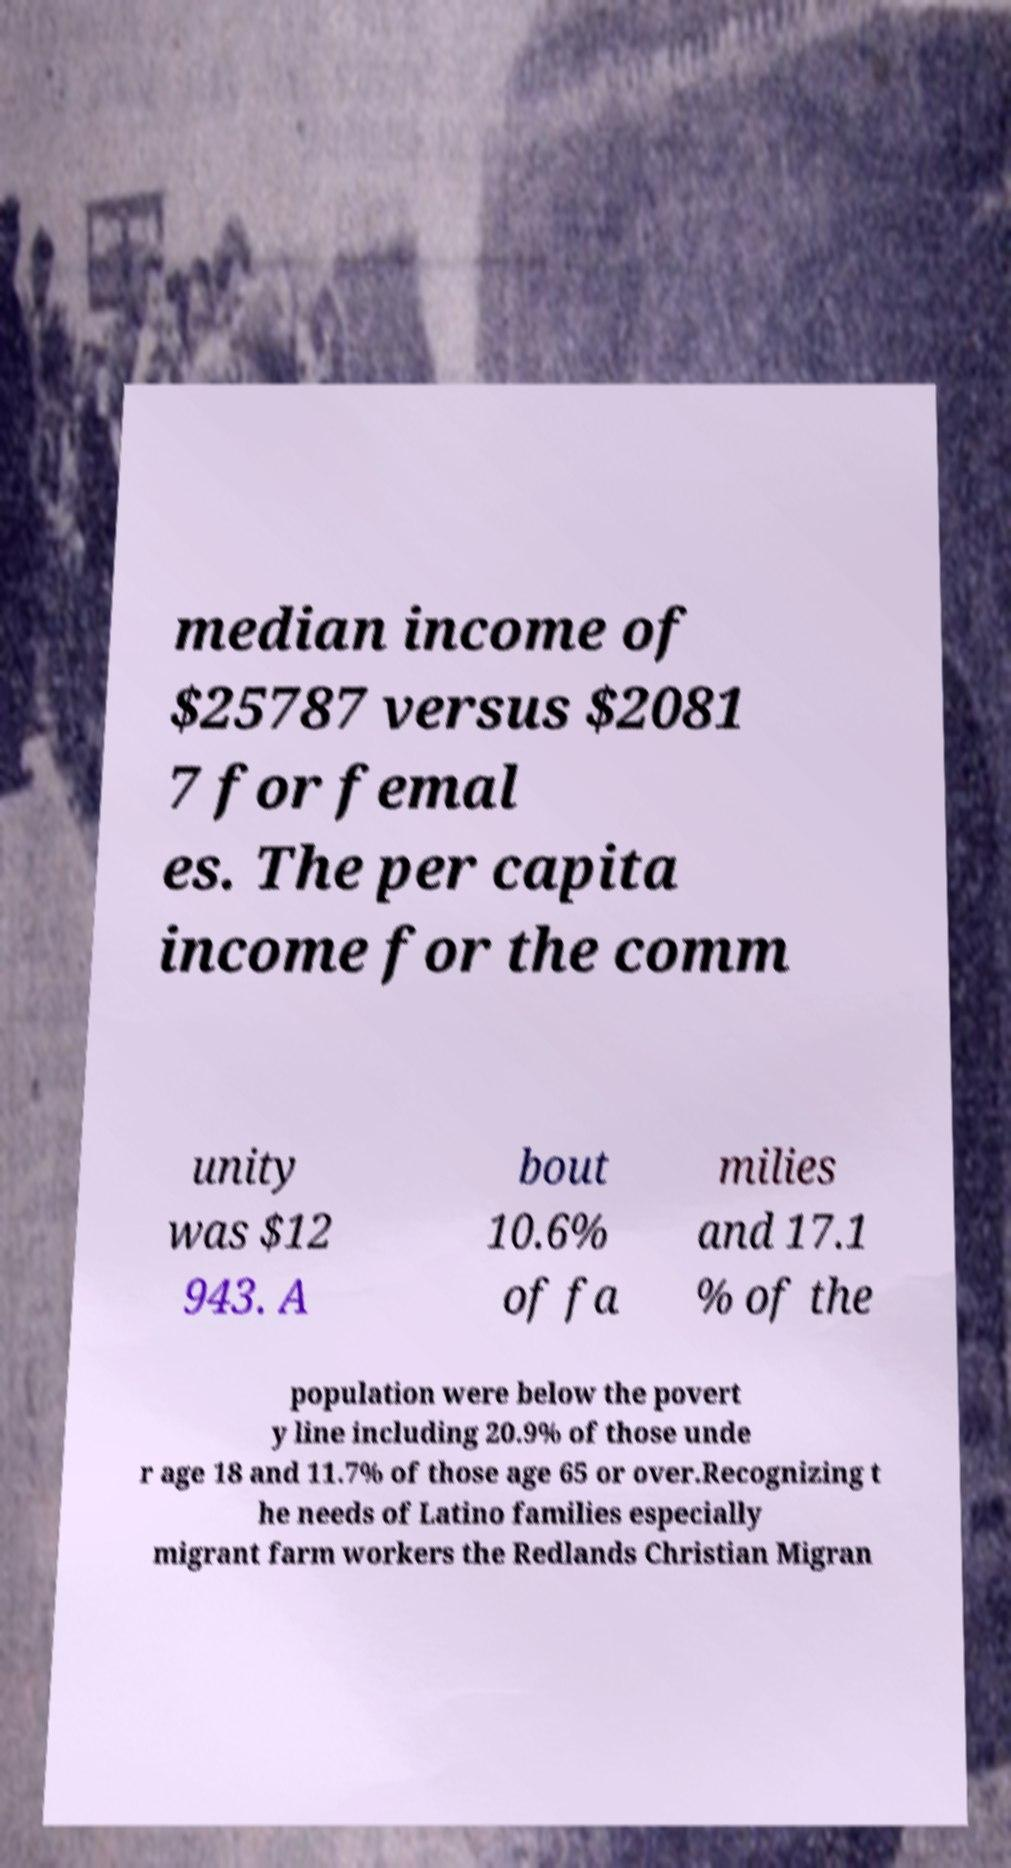Could you extract and type out the text from this image? median income of $25787 versus $2081 7 for femal es. The per capita income for the comm unity was $12 943. A bout 10.6% of fa milies and 17.1 % of the population were below the povert y line including 20.9% of those unde r age 18 and 11.7% of those age 65 or over.Recognizing t he needs of Latino families especially migrant farm workers the Redlands Christian Migran 